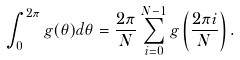Convert formula to latex. <formula><loc_0><loc_0><loc_500><loc_500>\int _ { 0 } ^ { 2 \pi } g ( \theta ) d \theta = \frac { 2 \pi } { N } \sum _ { i = 0 } ^ { N - 1 } g \left ( \frac { 2 \pi i } { N } \right ) .</formula> 